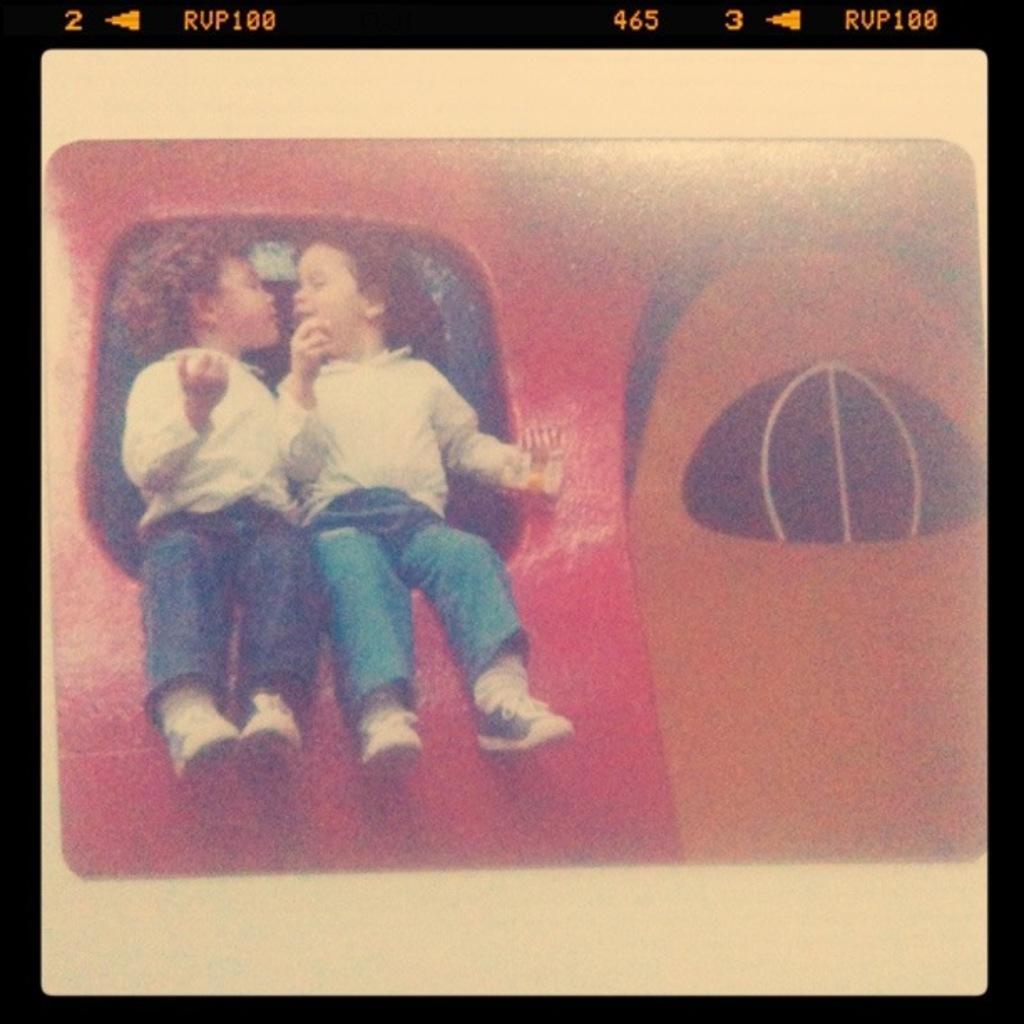In one or two sentences, can you explain what this image depicts? In this picture we can see a screen, on this screen we can see people, someone objects, at the top we can see symbols, some text, numbers on it. 